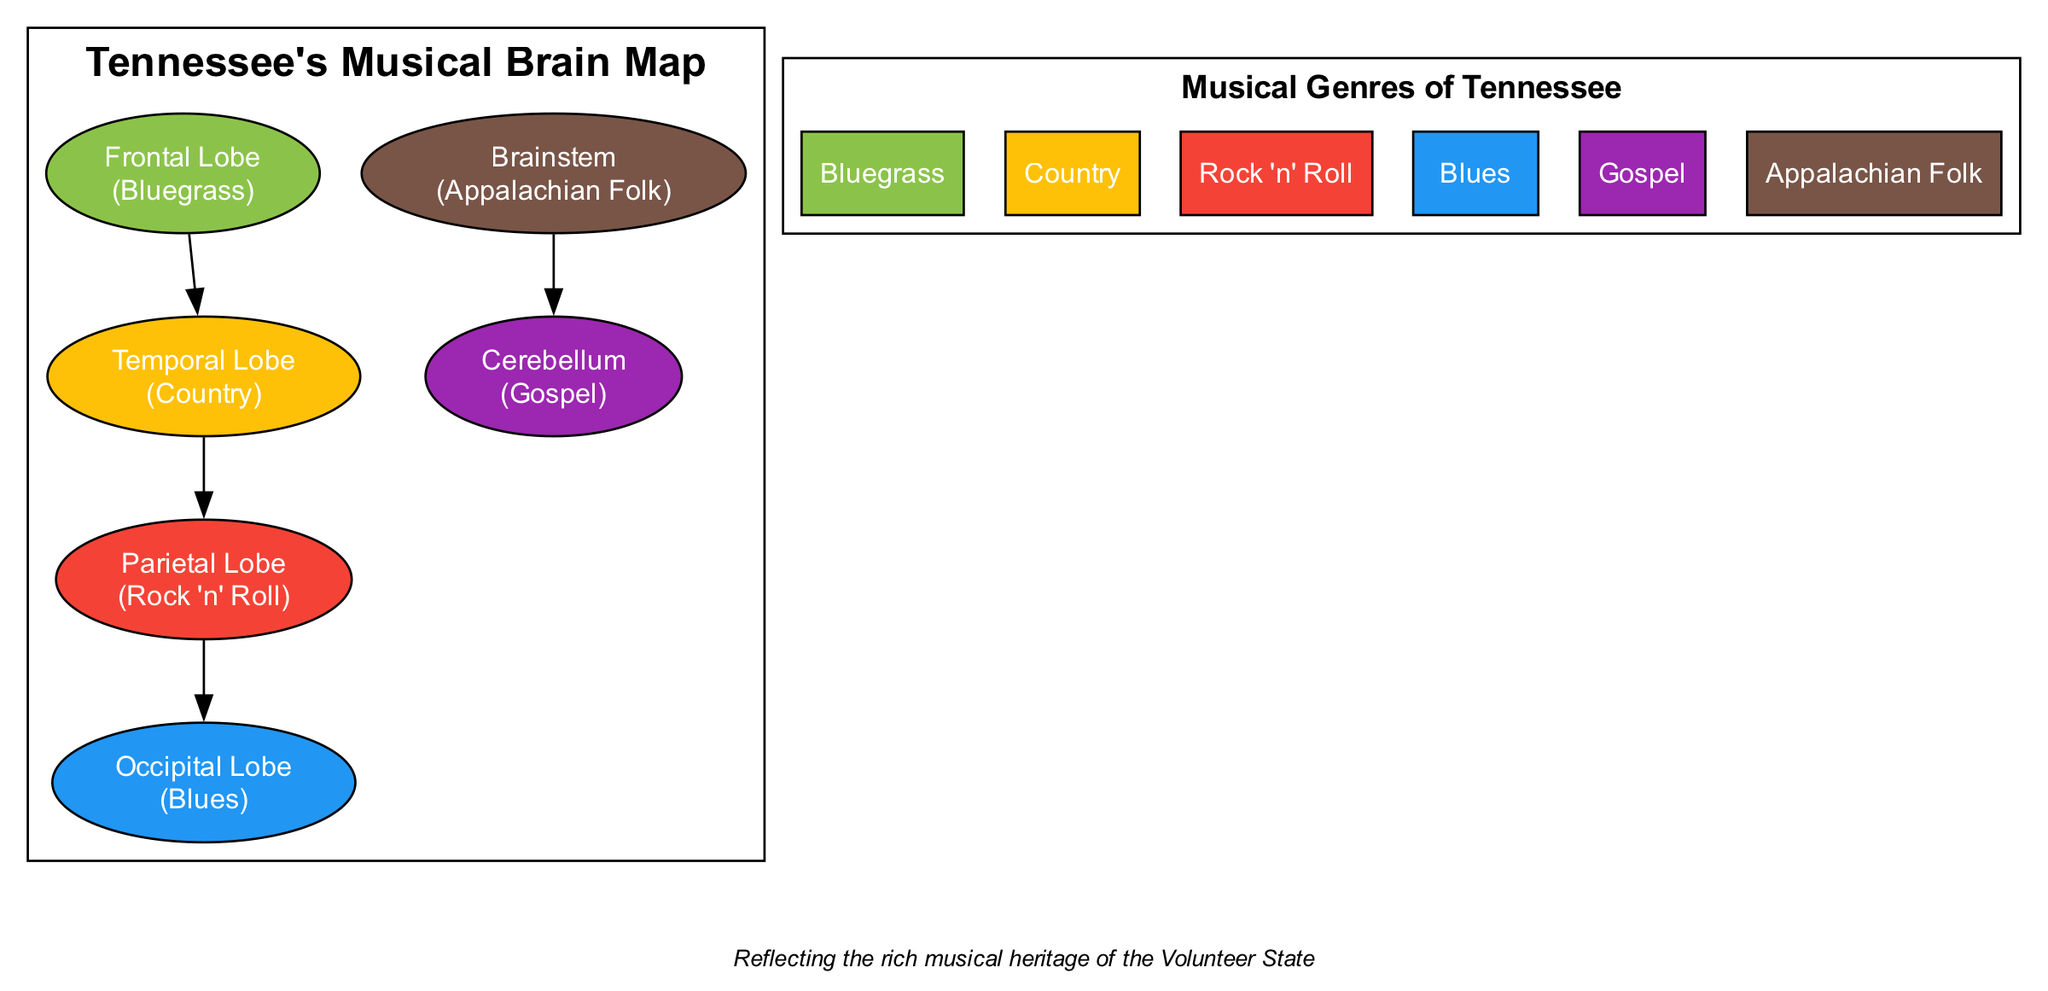What genre is represented by the Frontal Lobe? The Frontal Lobe is colored green (#8BC34A) and is associated with Bluegrass, as indicated directly within the node's label.
Answer: Bluegrass How many regions represent musical genres in the diagram? There are six nodes in total, each representing a different region of the brain associated with a musical genre, as listed in the brainRegions array.
Answer: 6 What color represents the Temporal Lobe? The Temporal Lobe is colored amber (#FFC107), which can be confirmed by examining the fill color code associated with the node labeled "Temporal Lobe."
Answer: #FFC107 Which genre is associated with the Cerebellum? The node for the Cerebellum indicates it is associated with Gospel, as stated in the node's label below the name "Cerebellum."
Answer: Gospel Which brain region connects the Frontal Lobe to the Parietal Lobe? The arrowed edge labeled between the Frontal Lobe and the Temporal Lobe shows the direct connection, illustrating their sequential relationship in the diagram.
Answer: Temporal Lobe What is the genre represented by the Occipital Lobe? This region is labeled specifically with Blues, indicated directly within the node that represents the Occipital Lobe.
Answer: Blues What is the relationship between the Brainstem and the Cerebellum? The diagram shows a directional edge from the Brainstem indicating a flow or connection directly to the Cerebellum. This reflects a relationship where the Brainstem supports or leads into the Cerebellum.
Answer: Connects to Cerebellum Is there a connection between the Parietal Lobe and the Brainstem? Upon inspecting the edges in the diagram, there is no direct connection indicated between the Parietal Lobe and the Brainstem. They are distinct in their connections.
Answer: No Which genre is represented by the region with the lowest color saturation? Assessing the colors used in the diagram, the Brainstem's color (#795548) appears to be the most muted compared to others, thus representing Appalachian Folk.
Answer: Appalachian Folk 